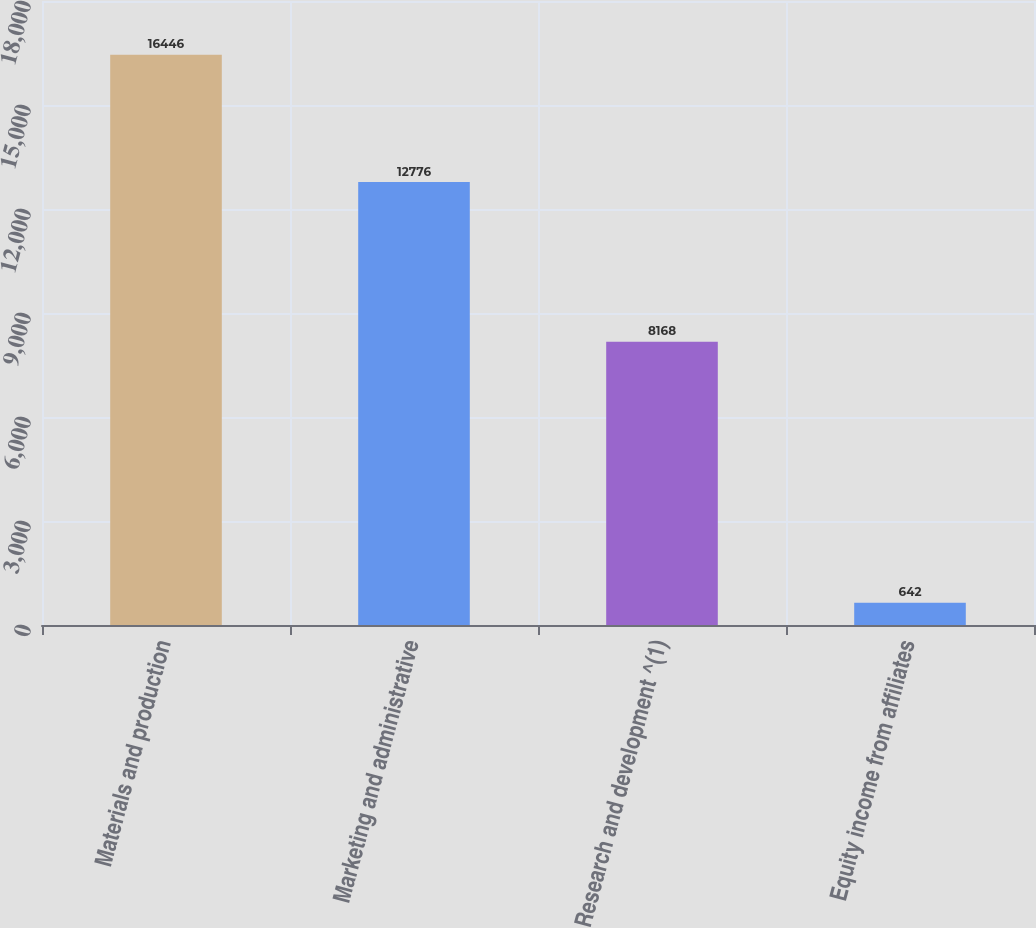Convert chart. <chart><loc_0><loc_0><loc_500><loc_500><bar_chart><fcel>Materials and production<fcel>Marketing and administrative<fcel>Research and development ^(1)<fcel>Equity income from affiliates<nl><fcel>16446<fcel>12776<fcel>8168<fcel>642<nl></chart> 